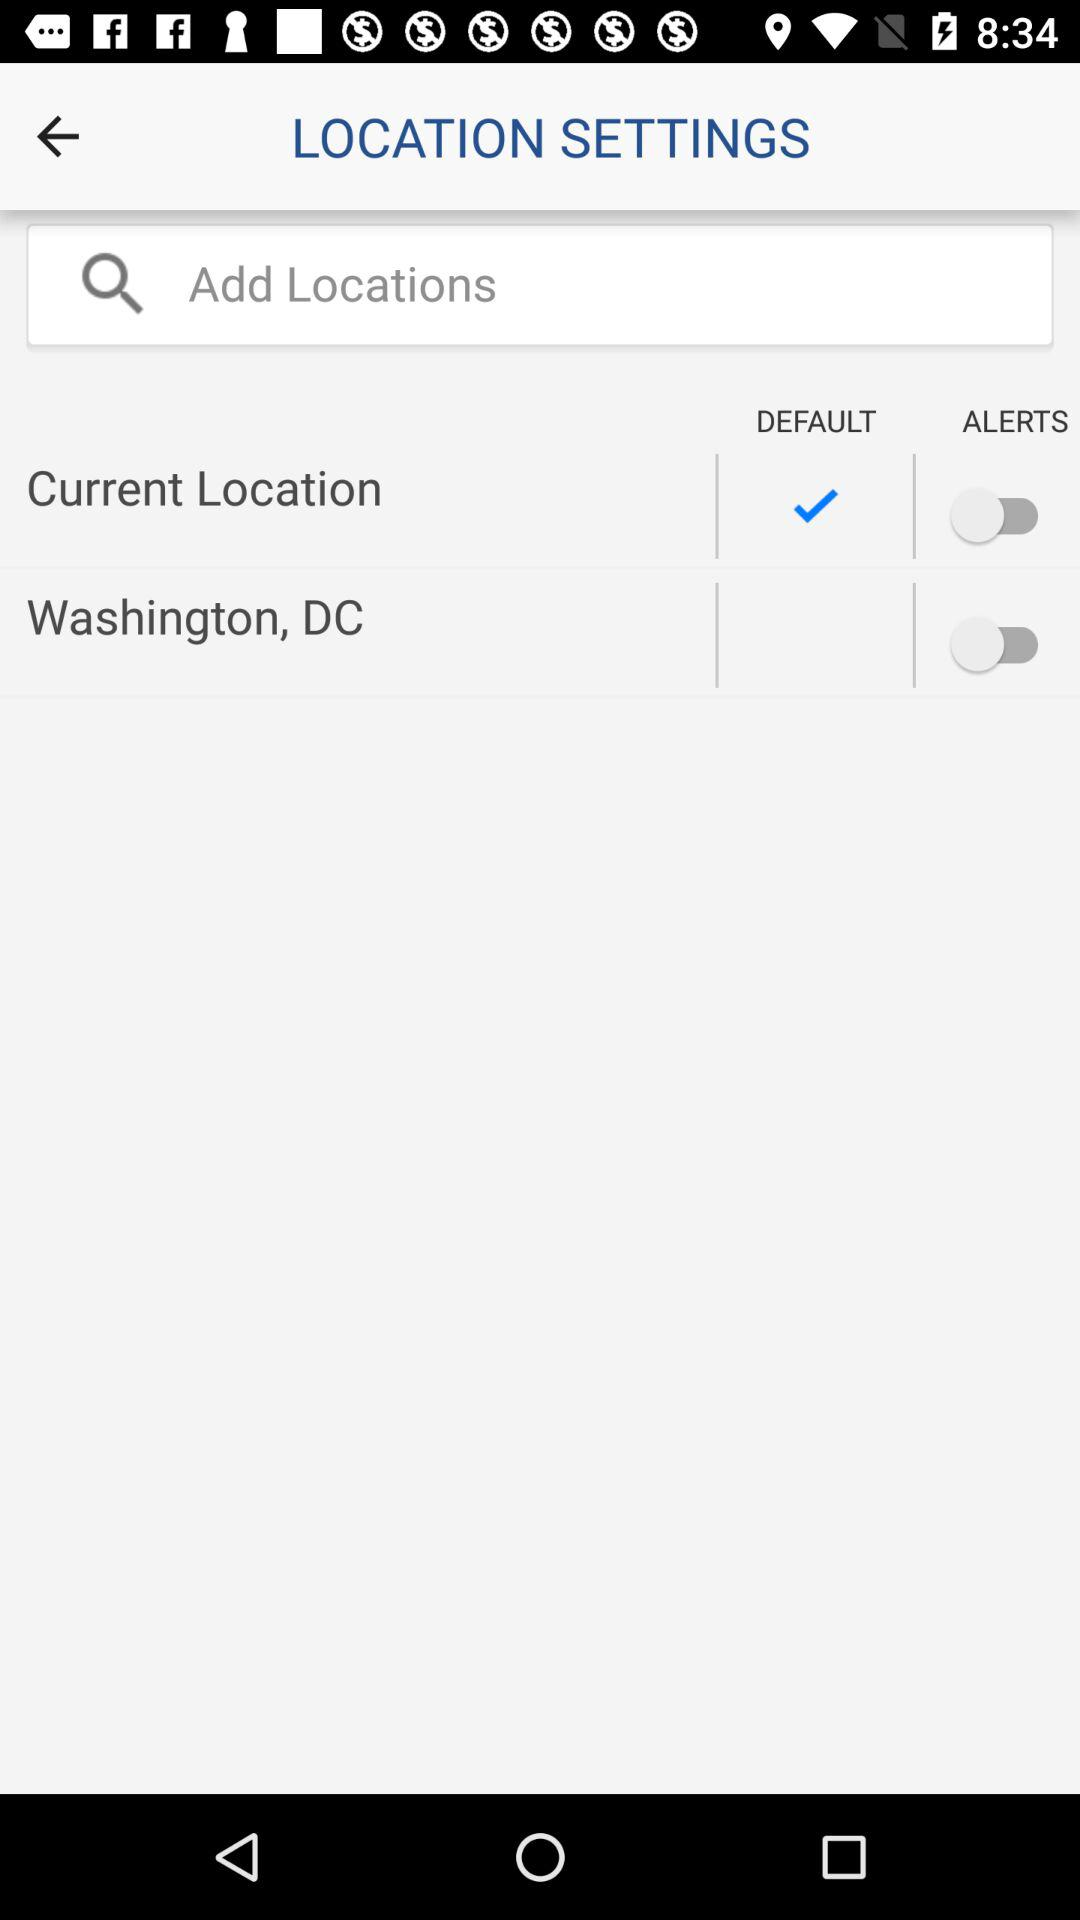What is the status of "Washington, DC"? The status of "Washington, DC" is "off". 